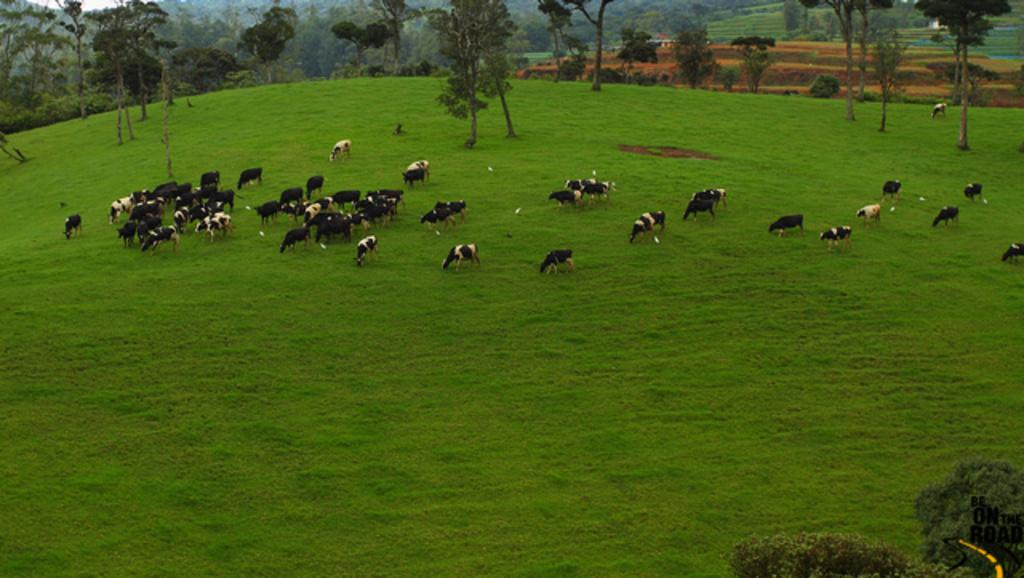What is present on the ground in the image? There are animals standing on the ground in the image. What can be seen in the distance behind the animals? There are trees, plants, grass, and other objects in the background of the image. What type of grape is your sister holding in the image? There is no sister or grape present in the image. 